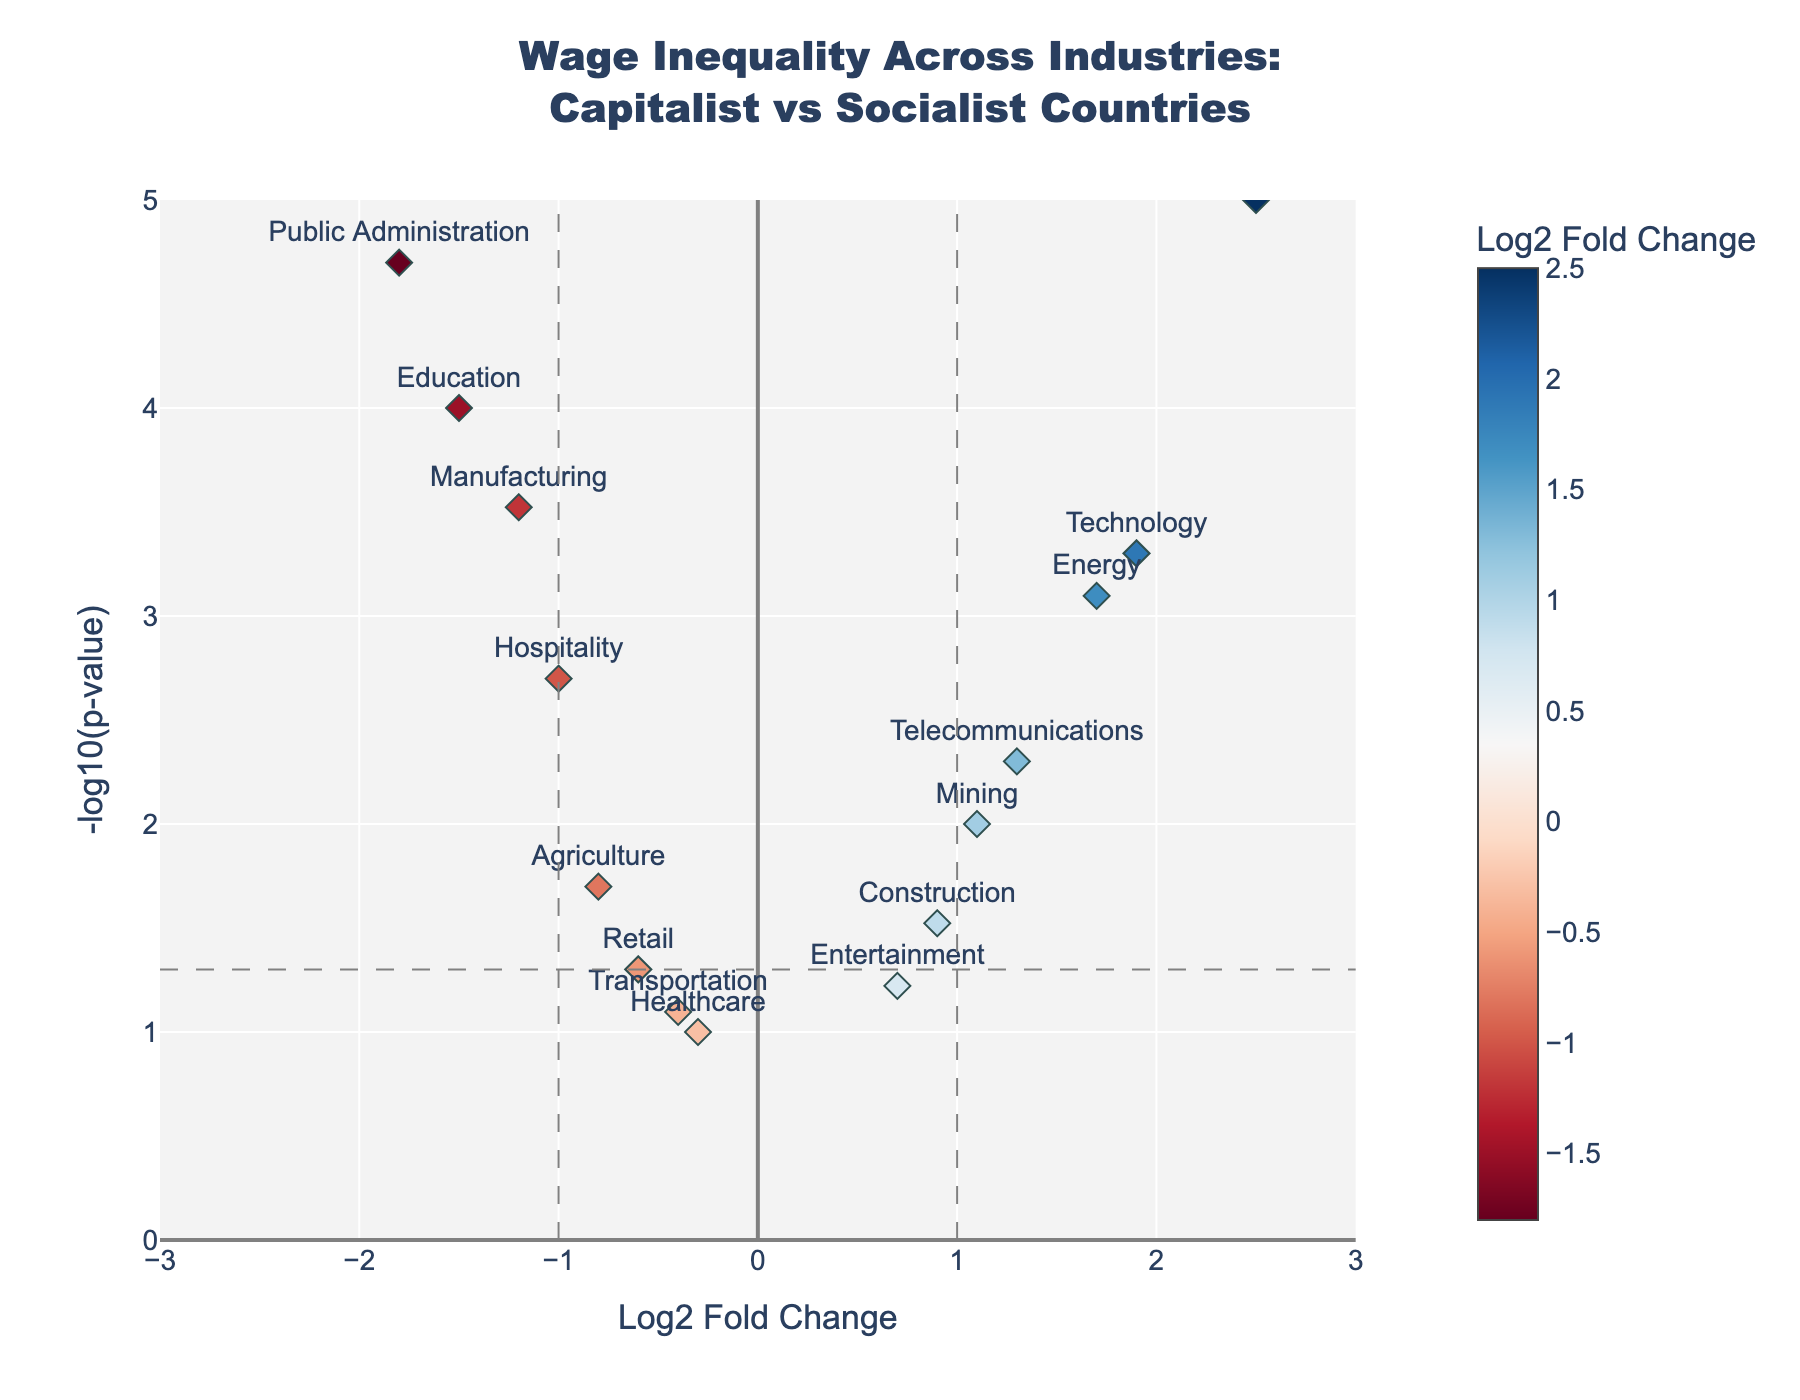what is the title of the plot? The title is typically provided at the top of the plot and summarizes the main topic or focus. In this case, the title reads "Wage Inequality Across Industries: Capitalist vs Socialist Countries".
Answer: Wage Inequality Across Industries: Capitalist vs Socialist Countries How many industries show significant wage inequality, defined as having a p-value less than 0.05? Significant wage inequality is indicated by points above the horizontal dashed line at y = -log10(0.05). Count all the industries above this line.
Answer: 10 Which industry has the highest wage inequality in capitalist countries (log2(FC) > 0) with the most statistical significance (smallest p-value)? Look for the point on the right side of the plot (log2(FC) > 0) with the highest y-value, which indicates the smallest p-value.
Answer: Finance Which industry shows the least significant wage inequality (largest p-value), regardless of direction? The industry with the smallest y-value, as a smaller y-value represents a larger p-value.
Answer: Healthcare What is the log2 fold change for the industry with the highest significance of wage equality in socialist countries (most negative log2(FC) and smallest p-value)? Look for the point on the left side with the most negative x-value and highest y-value.
Answer: Education Which industries have a log2 fold change between -1 and 1 but are not statistically significant (p-value > 0.05)? Identify the points within the vertical dashed lines at x = -1 and x = 1 and below the horizontal dashed line.
Answer: Retail, Healthcare, Transportation, Entertainment How many industries present a log2 fold change greater than 1 and have a p-value less than 0.05? Count the points on the right side of the plot (log2(FC) > 1) above the horizontal dashed line marking p-value = 0.05.
Answer: 4 What is the range of -log10(p-value) values for the industries depicted in the plot? The range is the difference between the maximum and minimum -log10(p-value) values shown on the y-axis.
Answer: 0 to 5 Between Technology and Agriculture, which industry shows higher significance in wage inequality? Compare the vertical positions of the points labeled "Technology" and "Agriculture". The higher the point, the smaller the p-value, indicating higher significance.
Answer: Technology Which industry named has a log2 fold change closest to zero, and is it significant? Identify the industry with a point closest to x = 0 and check if it is above or below the horizontal dashed line for significance.
Answer: Healthcare, Not significant 